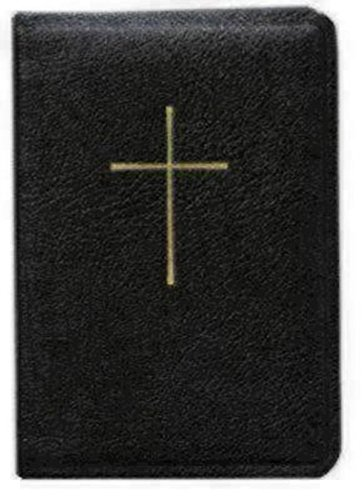Is this a comedy book? No, this book is not a comedy. The cross displayed on the cover suggests it is a book of serious religious nature, likely containing materials for Christian worship or guidance. 